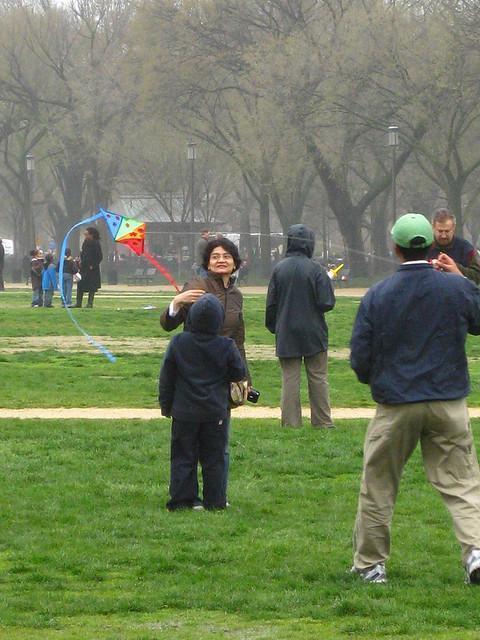Who is steering the flying object?
Pick the correct solution from the four options below to address the question.
Options: Man, boy, girl, woman. Man. 